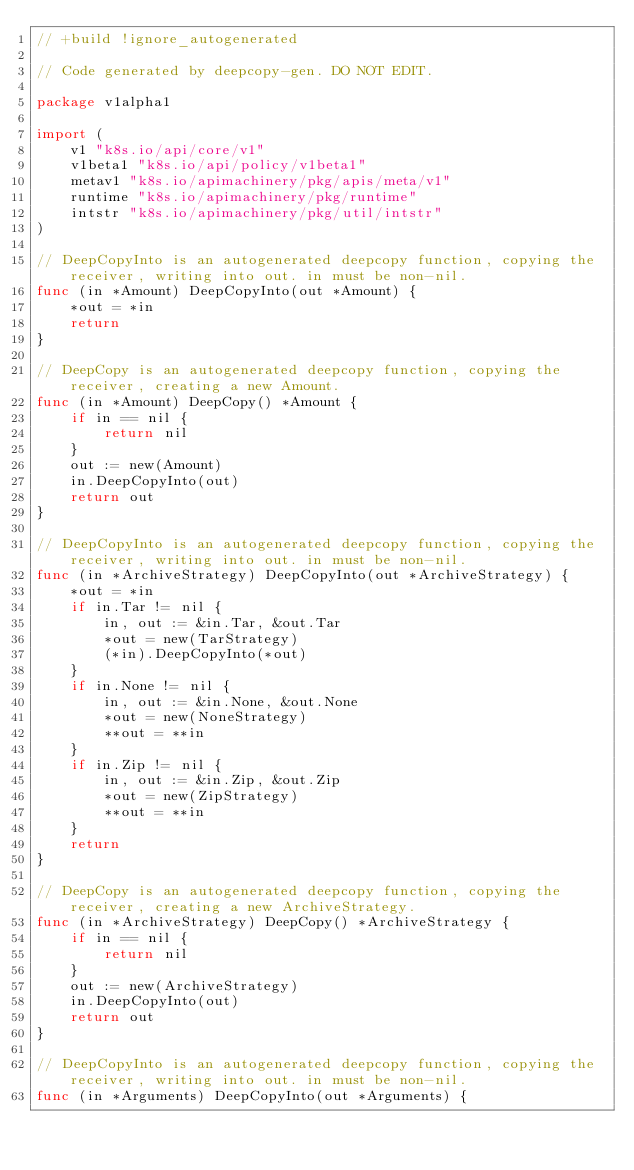<code> <loc_0><loc_0><loc_500><loc_500><_Go_>// +build !ignore_autogenerated

// Code generated by deepcopy-gen. DO NOT EDIT.

package v1alpha1

import (
	v1 "k8s.io/api/core/v1"
	v1beta1 "k8s.io/api/policy/v1beta1"
	metav1 "k8s.io/apimachinery/pkg/apis/meta/v1"
	runtime "k8s.io/apimachinery/pkg/runtime"
	intstr "k8s.io/apimachinery/pkg/util/intstr"
)

// DeepCopyInto is an autogenerated deepcopy function, copying the receiver, writing into out. in must be non-nil.
func (in *Amount) DeepCopyInto(out *Amount) {
	*out = *in
	return
}

// DeepCopy is an autogenerated deepcopy function, copying the receiver, creating a new Amount.
func (in *Amount) DeepCopy() *Amount {
	if in == nil {
		return nil
	}
	out := new(Amount)
	in.DeepCopyInto(out)
	return out
}

// DeepCopyInto is an autogenerated deepcopy function, copying the receiver, writing into out. in must be non-nil.
func (in *ArchiveStrategy) DeepCopyInto(out *ArchiveStrategy) {
	*out = *in
	if in.Tar != nil {
		in, out := &in.Tar, &out.Tar
		*out = new(TarStrategy)
		(*in).DeepCopyInto(*out)
	}
	if in.None != nil {
		in, out := &in.None, &out.None
		*out = new(NoneStrategy)
		**out = **in
	}
	if in.Zip != nil {
		in, out := &in.Zip, &out.Zip
		*out = new(ZipStrategy)
		**out = **in
	}
	return
}

// DeepCopy is an autogenerated deepcopy function, copying the receiver, creating a new ArchiveStrategy.
func (in *ArchiveStrategy) DeepCopy() *ArchiveStrategy {
	if in == nil {
		return nil
	}
	out := new(ArchiveStrategy)
	in.DeepCopyInto(out)
	return out
}

// DeepCopyInto is an autogenerated deepcopy function, copying the receiver, writing into out. in must be non-nil.
func (in *Arguments) DeepCopyInto(out *Arguments) {</code> 